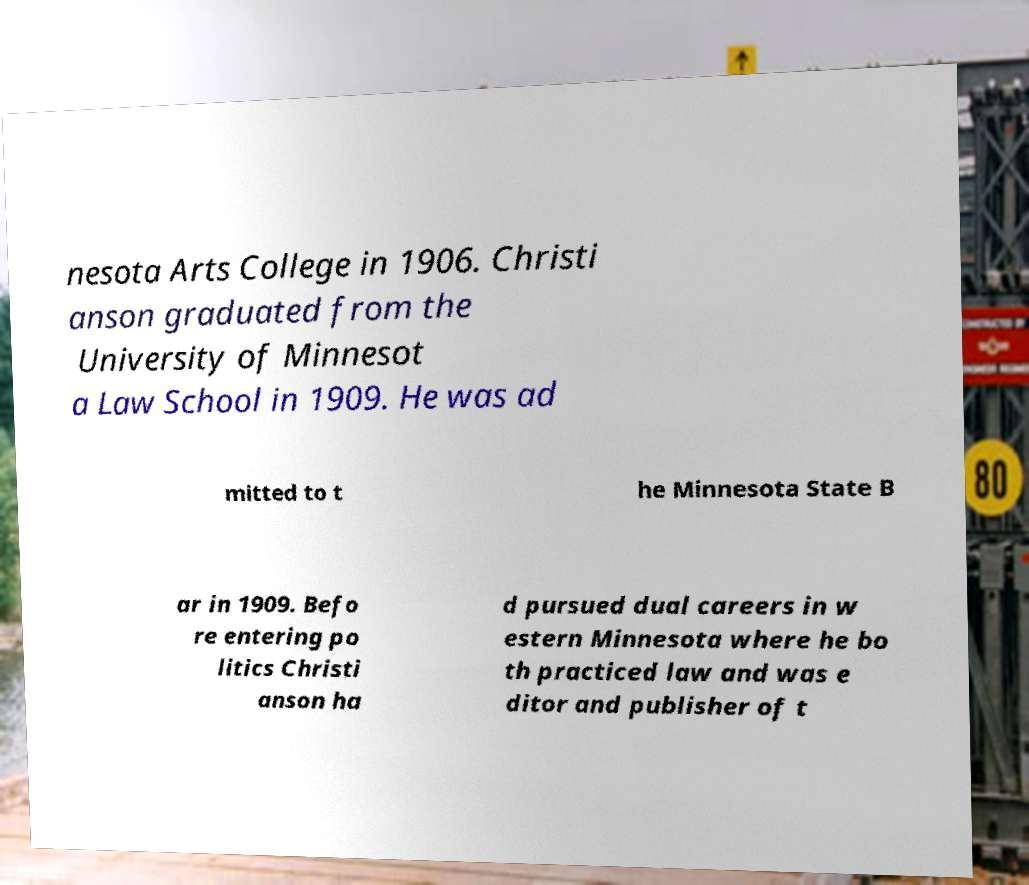Please identify and transcribe the text found in this image. nesota Arts College in 1906. Christi anson graduated from the University of Minnesot a Law School in 1909. He was ad mitted to t he Minnesota State B ar in 1909. Befo re entering po litics Christi anson ha d pursued dual careers in w estern Minnesota where he bo th practiced law and was e ditor and publisher of t 